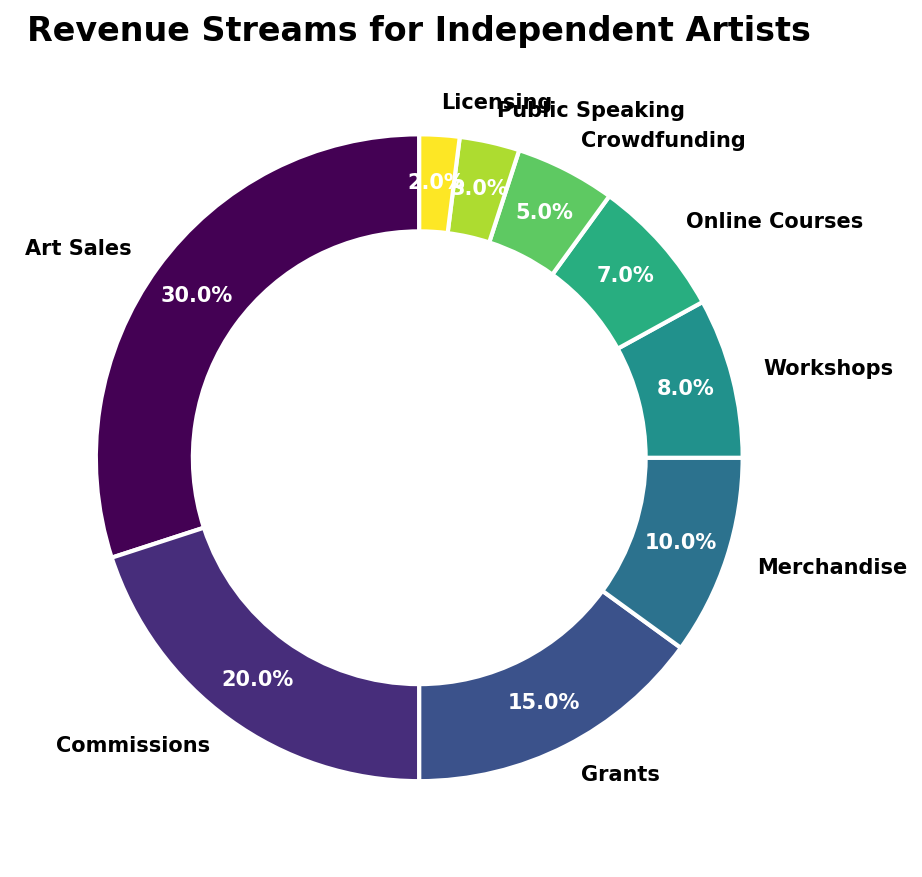What percentage do Commissions and Grants contribute to the total revenue? Add the percentages for Commissions and Grants: 20% (Commissions) + 15% (Grants) = 35%
Answer: 35% Which revenue source has the largest share? Art Sales has the highest percentage at 30%, making it the largest revenue source.
Answer: Art Sales What is the combined percentage of Online Courses, Workouts, and Merchandise? Add the percentages for Online Courses (7%), Workshops (8%), and Merchandise (10%): 7% + 8% + 10% = 25%
Answer: 25% Is the percentage for Crowdfunding greater than Licensing? The percentage for Crowdfunding is 5% while Licensing is 2%. 5% is greater than 2%, so Crowdfunding is greater.
Answer: Yes Which revenue source has the smallest share? Licensing has the smallest percentage at 2%, making it the revenue source with the smallest share.
Answer: Licensing How much more does Art Sales contribute compared to Merchandise? Subtract the percentage for Merchandise (10%) from Art Sales (30%): 30% - 10% = 20%
Answer: 20% Are Commissions or Merchandise a larger revenue source? Commissions has a percentage of 20%, which is higher than Merchandise's 10%, making Commissions the larger revenue source.
Answer: Commissions What is the total percentage of revenues from sources contributing less than 10% each? Add the percentages for Workshops (8%), Online Courses (7%), Crowdfunding (5%), Public Speaking (3%), and Licensing (2%): 8% + 7% + 5% + 3% + 2% = 25%
Answer: 25% What is the percentage difference between Art Sales and Grants? Subtract the percentage for Grants (15%) from Art Sales (30%): 30% - 15% = 15%
Answer: 15% What are the two sources with the closest percentage values? Workshops (8%) and Online Courses (7%) have the closest values with a difference of only 1%.
Answer: Workshops and Online Courses 